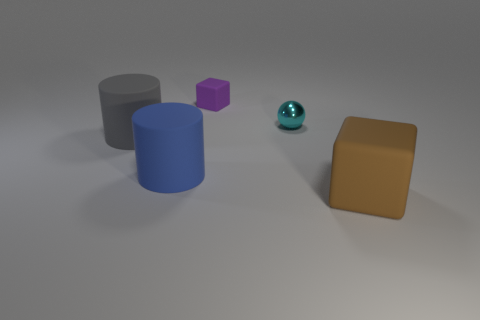Add 2 shiny spheres. How many objects exist? 7 Subtract all spheres. How many objects are left? 4 Add 4 small yellow metallic objects. How many small yellow metallic objects exist? 4 Subtract 0 red cylinders. How many objects are left? 5 Subtract all large cylinders. Subtract all small gray shiny cubes. How many objects are left? 3 Add 4 metal balls. How many metal balls are left? 5 